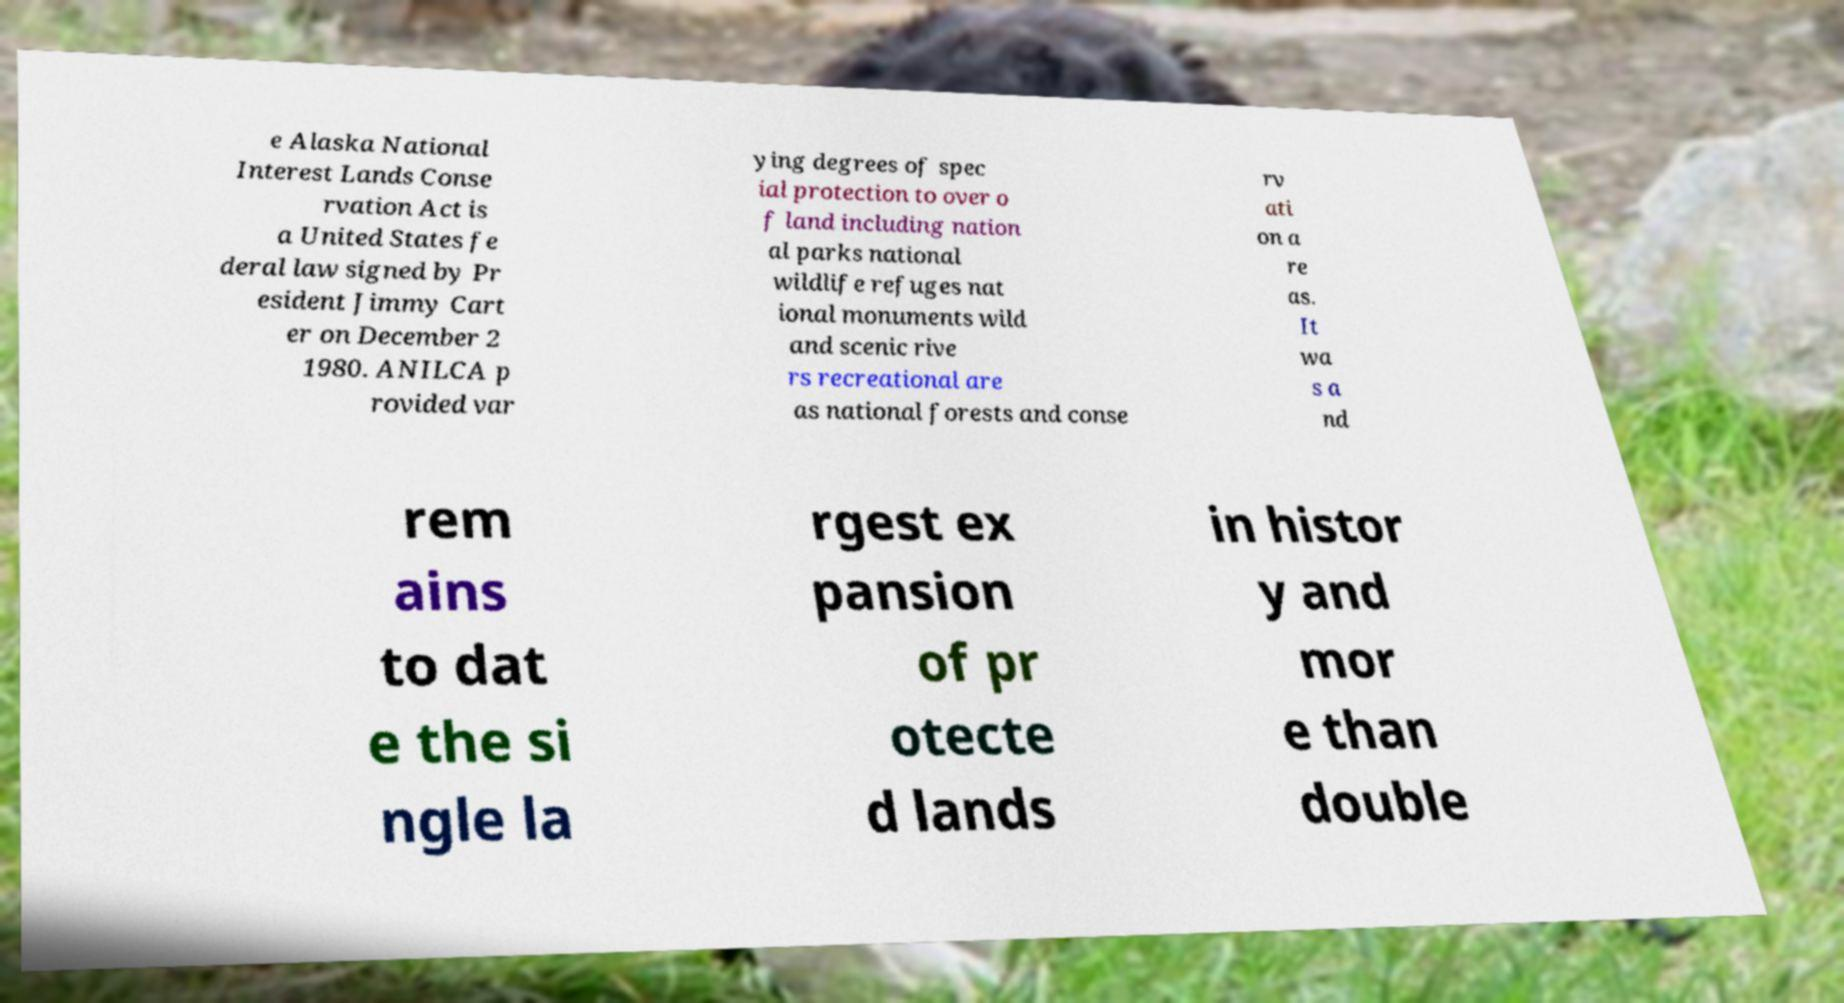What messages or text are displayed in this image? I need them in a readable, typed format. e Alaska National Interest Lands Conse rvation Act is a United States fe deral law signed by Pr esident Jimmy Cart er on December 2 1980. ANILCA p rovided var ying degrees of spec ial protection to over o f land including nation al parks national wildlife refuges nat ional monuments wild and scenic rive rs recreational are as national forests and conse rv ati on a re as. It wa s a nd rem ains to dat e the si ngle la rgest ex pansion of pr otecte d lands in histor y and mor e than double 